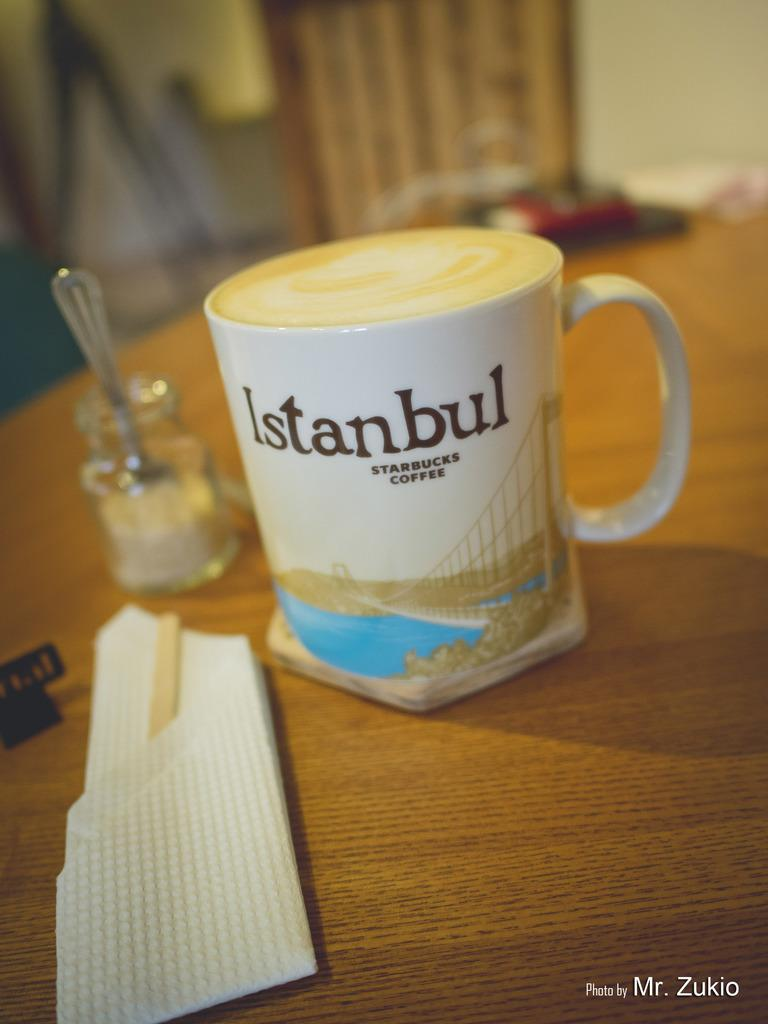What is the main piece of furniture in the image? There is a table in the image. What is placed on the table? A tea cup, a jar, a spoon, and tissue paper are on the table. Can you describe any other objects on the table? There are other objects on the table, but their specific details are not mentioned in the provided facts. What is the condition of the background in the image? The background of the image is blurred. What type of voyage is depicted in the image? There is no voyage depicted in the image; it features a table with various objects on it. How many oranges are visible on the table in the image? There are no oranges present in the image. 